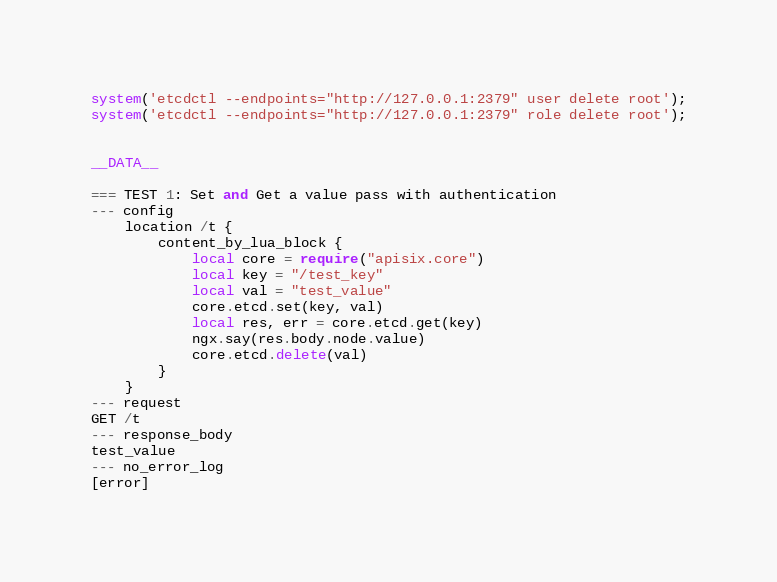Convert code to text. <code><loc_0><loc_0><loc_500><loc_500><_Perl_>system('etcdctl --endpoints="http://127.0.0.1:2379" user delete root');
system('etcdctl --endpoints="http://127.0.0.1:2379" role delete root');


__DATA__

=== TEST 1: Set and Get a value pass with authentication
--- config
    location /t {
        content_by_lua_block {
            local core = require("apisix.core")
            local key = "/test_key"
            local val = "test_value"
            core.etcd.set(key, val)
            local res, err = core.etcd.get(key)
            ngx.say(res.body.node.value)
            core.etcd.delete(val)
        }
    }
--- request
GET /t
--- response_body
test_value
--- no_error_log
[error]
</code> 